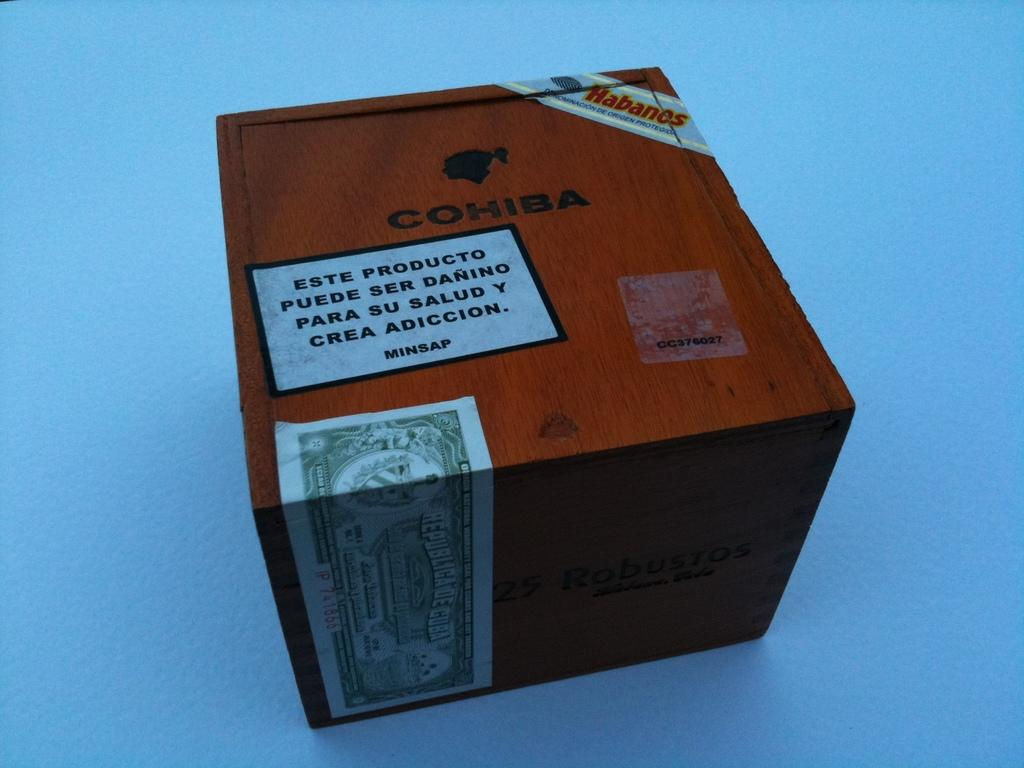<image>
Create a compact narrative representing the image presented. A wooden box is marked Cohiba in black lettering. 